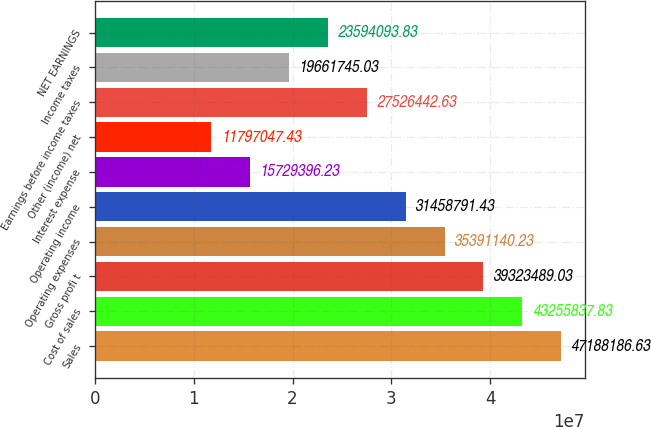Convert chart. <chart><loc_0><loc_0><loc_500><loc_500><bar_chart><fcel>Sales<fcel>Cost of sales<fcel>Gross profi t<fcel>Operating expenses<fcel>Operating income<fcel>Interest expense<fcel>Other (income) net<fcel>Earnings before income taxes<fcel>Income taxes<fcel>NET EARNINGS<nl><fcel>4.71882e+07<fcel>4.32558e+07<fcel>3.93235e+07<fcel>3.53911e+07<fcel>3.14588e+07<fcel>1.57294e+07<fcel>1.1797e+07<fcel>2.75264e+07<fcel>1.96617e+07<fcel>2.35941e+07<nl></chart> 